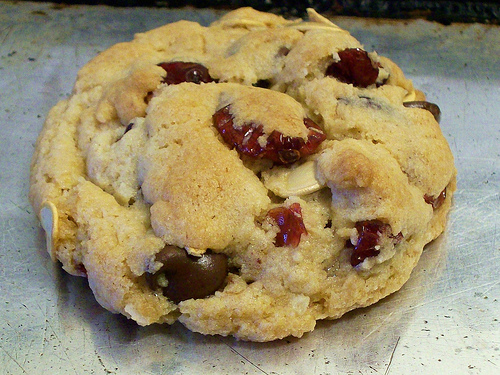<image>
Can you confirm if the food is next to the plate? No. The food is not positioned next to the plate. They are located in different areas of the scene. 